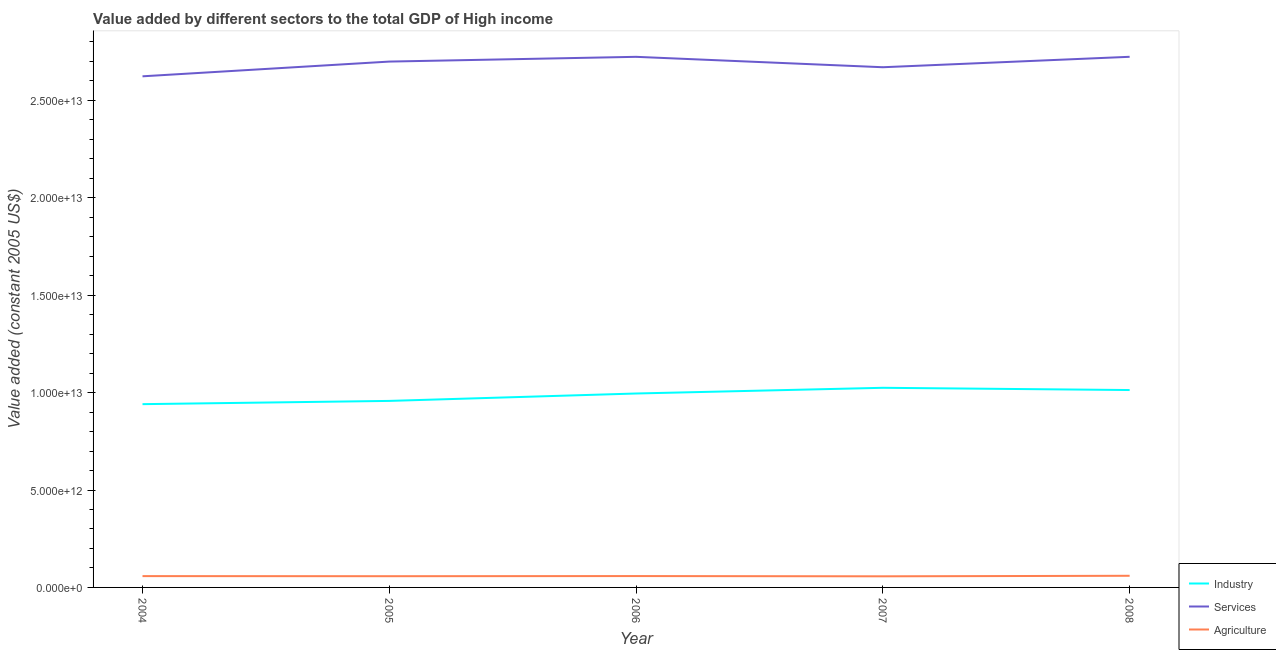Is the number of lines equal to the number of legend labels?
Provide a short and direct response. Yes. What is the value added by services in 2005?
Provide a succinct answer. 2.70e+13. Across all years, what is the maximum value added by services?
Ensure brevity in your answer.  2.72e+13. Across all years, what is the minimum value added by agricultural sector?
Offer a terse response. 5.71e+11. In which year was the value added by services maximum?
Make the answer very short. 2008. In which year was the value added by agricultural sector minimum?
Make the answer very short. 2007. What is the total value added by services in the graph?
Provide a short and direct response. 1.34e+14. What is the difference between the value added by agricultural sector in 2007 and that in 2008?
Provide a succinct answer. -2.67e+1. What is the difference between the value added by industrial sector in 2007 and the value added by services in 2004?
Offer a terse response. -1.60e+13. What is the average value added by industrial sector per year?
Ensure brevity in your answer.  9.86e+12. In the year 2008, what is the difference between the value added by services and value added by industrial sector?
Provide a succinct answer. 1.71e+13. What is the ratio of the value added by services in 2004 to that in 2005?
Offer a very short reply. 0.97. Is the value added by services in 2005 less than that in 2007?
Keep it short and to the point. No. What is the difference between the highest and the second highest value added by agricultural sector?
Offer a terse response. 1.40e+1. What is the difference between the highest and the lowest value added by industrial sector?
Give a very brief answer. 8.39e+11. Is the sum of the value added by agricultural sector in 2005 and 2008 greater than the maximum value added by industrial sector across all years?
Give a very brief answer. No. Does the value added by industrial sector monotonically increase over the years?
Ensure brevity in your answer.  No. Is the value added by services strictly greater than the value added by industrial sector over the years?
Your response must be concise. Yes. Is the value added by agricultural sector strictly less than the value added by services over the years?
Your answer should be compact. Yes. What is the difference between two consecutive major ticks on the Y-axis?
Your answer should be very brief. 5.00e+12. Where does the legend appear in the graph?
Provide a short and direct response. Bottom right. How are the legend labels stacked?
Give a very brief answer. Vertical. What is the title of the graph?
Your response must be concise. Value added by different sectors to the total GDP of High income. What is the label or title of the Y-axis?
Your answer should be compact. Value added (constant 2005 US$). What is the Value added (constant 2005 US$) in Industry in 2004?
Provide a short and direct response. 9.41e+12. What is the Value added (constant 2005 US$) of Services in 2004?
Provide a short and direct response. 2.62e+13. What is the Value added (constant 2005 US$) in Agriculture in 2004?
Offer a very short reply. 5.81e+11. What is the Value added (constant 2005 US$) of Industry in 2005?
Your answer should be very brief. 9.57e+12. What is the Value added (constant 2005 US$) of Services in 2005?
Provide a succinct answer. 2.70e+13. What is the Value added (constant 2005 US$) in Agriculture in 2005?
Provide a short and direct response. 5.76e+11. What is the Value added (constant 2005 US$) of Industry in 2006?
Give a very brief answer. 9.95e+12. What is the Value added (constant 2005 US$) of Services in 2006?
Provide a short and direct response. 2.72e+13. What is the Value added (constant 2005 US$) of Agriculture in 2006?
Provide a short and direct response. 5.84e+11. What is the Value added (constant 2005 US$) in Industry in 2007?
Offer a terse response. 1.02e+13. What is the Value added (constant 2005 US$) of Services in 2007?
Give a very brief answer. 2.67e+13. What is the Value added (constant 2005 US$) in Agriculture in 2007?
Keep it short and to the point. 5.71e+11. What is the Value added (constant 2005 US$) in Industry in 2008?
Provide a succinct answer. 1.01e+13. What is the Value added (constant 2005 US$) of Services in 2008?
Ensure brevity in your answer.  2.72e+13. What is the Value added (constant 2005 US$) in Agriculture in 2008?
Offer a very short reply. 5.98e+11. Across all years, what is the maximum Value added (constant 2005 US$) in Industry?
Offer a terse response. 1.02e+13. Across all years, what is the maximum Value added (constant 2005 US$) in Services?
Keep it short and to the point. 2.72e+13. Across all years, what is the maximum Value added (constant 2005 US$) in Agriculture?
Make the answer very short. 5.98e+11. Across all years, what is the minimum Value added (constant 2005 US$) in Industry?
Provide a succinct answer. 9.41e+12. Across all years, what is the minimum Value added (constant 2005 US$) of Services?
Make the answer very short. 2.62e+13. Across all years, what is the minimum Value added (constant 2005 US$) of Agriculture?
Offer a very short reply. 5.71e+11. What is the total Value added (constant 2005 US$) of Industry in the graph?
Offer a very short reply. 4.93e+13. What is the total Value added (constant 2005 US$) of Services in the graph?
Your answer should be compact. 1.34e+14. What is the total Value added (constant 2005 US$) of Agriculture in the graph?
Your answer should be very brief. 2.91e+12. What is the difference between the Value added (constant 2005 US$) in Industry in 2004 and that in 2005?
Make the answer very short. -1.67e+11. What is the difference between the Value added (constant 2005 US$) of Services in 2004 and that in 2005?
Give a very brief answer. -7.56e+11. What is the difference between the Value added (constant 2005 US$) of Agriculture in 2004 and that in 2005?
Provide a short and direct response. 4.40e+09. What is the difference between the Value added (constant 2005 US$) of Industry in 2004 and that in 2006?
Make the answer very short. -5.47e+11. What is the difference between the Value added (constant 2005 US$) of Services in 2004 and that in 2006?
Keep it short and to the point. -1.00e+12. What is the difference between the Value added (constant 2005 US$) in Agriculture in 2004 and that in 2006?
Your answer should be very brief. -2.66e+09. What is the difference between the Value added (constant 2005 US$) of Industry in 2004 and that in 2007?
Your answer should be compact. -8.39e+11. What is the difference between the Value added (constant 2005 US$) of Services in 2004 and that in 2007?
Give a very brief answer. -4.66e+11. What is the difference between the Value added (constant 2005 US$) of Agriculture in 2004 and that in 2007?
Offer a very short reply. 1.00e+1. What is the difference between the Value added (constant 2005 US$) in Industry in 2004 and that in 2008?
Offer a very short reply. -7.24e+11. What is the difference between the Value added (constant 2005 US$) of Services in 2004 and that in 2008?
Offer a terse response. -1.00e+12. What is the difference between the Value added (constant 2005 US$) of Agriculture in 2004 and that in 2008?
Your response must be concise. -1.66e+1. What is the difference between the Value added (constant 2005 US$) of Industry in 2005 and that in 2006?
Ensure brevity in your answer.  -3.80e+11. What is the difference between the Value added (constant 2005 US$) of Services in 2005 and that in 2006?
Give a very brief answer. -2.44e+11. What is the difference between the Value added (constant 2005 US$) of Agriculture in 2005 and that in 2006?
Your answer should be very brief. -7.05e+09. What is the difference between the Value added (constant 2005 US$) in Industry in 2005 and that in 2007?
Provide a short and direct response. -6.73e+11. What is the difference between the Value added (constant 2005 US$) in Services in 2005 and that in 2007?
Ensure brevity in your answer.  2.90e+11. What is the difference between the Value added (constant 2005 US$) of Agriculture in 2005 and that in 2007?
Provide a succinct answer. 5.63e+09. What is the difference between the Value added (constant 2005 US$) in Industry in 2005 and that in 2008?
Your response must be concise. -5.58e+11. What is the difference between the Value added (constant 2005 US$) in Services in 2005 and that in 2008?
Your answer should be compact. -2.45e+11. What is the difference between the Value added (constant 2005 US$) in Agriculture in 2005 and that in 2008?
Provide a short and direct response. -2.10e+1. What is the difference between the Value added (constant 2005 US$) in Industry in 2006 and that in 2007?
Make the answer very short. -2.92e+11. What is the difference between the Value added (constant 2005 US$) in Services in 2006 and that in 2007?
Offer a terse response. 5.34e+11. What is the difference between the Value added (constant 2005 US$) in Agriculture in 2006 and that in 2007?
Your answer should be very brief. 1.27e+1. What is the difference between the Value added (constant 2005 US$) of Industry in 2006 and that in 2008?
Your answer should be very brief. -1.77e+11. What is the difference between the Value added (constant 2005 US$) in Services in 2006 and that in 2008?
Give a very brief answer. -1.33e+09. What is the difference between the Value added (constant 2005 US$) in Agriculture in 2006 and that in 2008?
Your answer should be very brief. -1.40e+1. What is the difference between the Value added (constant 2005 US$) in Industry in 2007 and that in 2008?
Ensure brevity in your answer.  1.15e+11. What is the difference between the Value added (constant 2005 US$) in Services in 2007 and that in 2008?
Your answer should be very brief. -5.36e+11. What is the difference between the Value added (constant 2005 US$) of Agriculture in 2007 and that in 2008?
Your response must be concise. -2.67e+1. What is the difference between the Value added (constant 2005 US$) of Industry in 2004 and the Value added (constant 2005 US$) of Services in 2005?
Keep it short and to the point. -1.76e+13. What is the difference between the Value added (constant 2005 US$) in Industry in 2004 and the Value added (constant 2005 US$) in Agriculture in 2005?
Your response must be concise. 8.83e+12. What is the difference between the Value added (constant 2005 US$) of Services in 2004 and the Value added (constant 2005 US$) of Agriculture in 2005?
Make the answer very short. 2.57e+13. What is the difference between the Value added (constant 2005 US$) in Industry in 2004 and the Value added (constant 2005 US$) in Services in 2006?
Offer a very short reply. -1.78e+13. What is the difference between the Value added (constant 2005 US$) in Industry in 2004 and the Value added (constant 2005 US$) in Agriculture in 2006?
Provide a succinct answer. 8.82e+12. What is the difference between the Value added (constant 2005 US$) of Services in 2004 and the Value added (constant 2005 US$) of Agriculture in 2006?
Ensure brevity in your answer.  2.57e+13. What is the difference between the Value added (constant 2005 US$) in Industry in 2004 and the Value added (constant 2005 US$) in Services in 2007?
Your response must be concise. -1.73e+13. What is the difference between the Value added (constant 2005 US$) of Industry in 2004 and the Value added (constant 2005 US$) of Agriculture in 2007?
Provide a short and direct response. 8.84e+12. What is the difference between the Value added (constant 2005 US$) of Services in 2004 and the Value added (constant 2005 US$) of Agriculture in 2007?
Ensure brevity in your answer.  2.57e+13. What is the difference between the Value added (constant 2005 US$) in Industry in 2004 and the Value added (constant 2005 US$) in Services in 2008?
Give a very brief answer. -1.78e+13. What is the difference between the Value added (constant 2005 US$) in Industry in 2004 and the Value added (constant 2005 US$) in Agriculture in 2008?
Provide a short and direct response. 8.81e+12. What is the difference between the Value added (constant 2005 US$) of Services in 2004 and the Value added (constant 2005 US$) of Agriculture in 2008?
Keep it short and to the point. 2.56e+13. What is the difference between the Value added (constant 2005 US$) of Industry in 2005 and the Value added (constant 2005 US$) of Services in 2006?
Make the answer very short. -1.77e+13. What is the difference between the Value added (constant 2005 US$) in Industry in 2005 and the Value added (constant 2005 US$) in Agriculture in 2006?
Your response must be concise. 8.99e+12. What is the difference between the Value added (constant 2005 US$) in Services in 2005 and the Value added (constant 2005 US$) in Agriculture in 2006?
Your answer should be very brief. 2.64e+13. What is the difference between the Value added (constant 2005 US$) in Industry in 2005 and the Value added (constant 2005 US$) in Services in 2007?
Offer a very short reply. -1.71e+13. What is the difference between the Value added (constant 2005 US$) of Industry in 2005 and the Value added (constant 2005 US$) of Agriculture in 2007?
Offer a terse response. 9.00e+12. What is the difference between the Value added (constant 2005 US$) of Services in 2005 and the Value added (constant 2005 US$) of Agriculture in 2007?
Your response must be concise. 2.64e+13. What is the difference between the Value added (constant 2005 US$) in Industry in 2005 and the Value added (constant 2005 US$) in Services in 2008?
Give a very brief answer. -1.77e+13. What is the difference between the Value added (constant 2005 US$) in Industry in 2005 and the Value added (constant 2005 US$) in Agriculture in 2008?
Your response must be concise. 8.98e+12. What is the difference between the Value added (constant 2005 US$) of Services in 2005 and the Value added (constant 2005 US$) of Agriculture in 2008?
Provide a short and direct response. 2.64e+13. What is the difference between the Value added (constant 2005 US$) of Industry in 2006 and the Value added (constant 2005 US$) of Services in 2007?
Offer a terse response. -1.67e+13. What is the difference between the Value added (constant 2005 US$) of Industry in 2006 and the Value added (constant 2005 US$) of Agriculture in 2007?
Offer a terse response. 9.38e+12. What is the difference between the Value added (constant 2005 US$) of Services in 2006 and the Value added (constant 2005 US$) of Agriculture in 2007?
Your response must be concise. 2.67e+13. What is the difference between the Value added (constant 2005 US$) of Industry in 2006 and the Value added (constant 2005 US$) of Services in 2008?
Offer a terse response. -1.73e+13. What is the difference between the Value added (constant 2005 US$) of Industry in 2006 and the Value added (constant 2005 US$) of Agriculture in 2008?
Make the answer very short. 9.36e+12. What is the difference between the Value added (constant 2005 US$) in Services in 2006 and the Value added (constant 2005 US$) in Agriculture in 2008?
Keep it short and to the point. 2.66e+13. What is the difference between the Value added (constant 2005 US$) of Industry in 2007 and the Value added (constant 2005 US$) of Services in 2008?
Your response must be concise. -1.70e+13. What is the difference between the Value added (constant 2005 US$) in Industry in 2007 and the Value added (constant 2005 US$) in Agriculture in 2008?
Give a very brief answer. 9.65e+12. What is the difference between the Value added (constant 2005 US$) in Services in 2007 and the Value added (constant 2005 US$) in Agriculture in 2008?
Ensure brevity in your answer.  2.61e+13. What is the average Value added (constant 2005 US$) of Industry per year?
Provide a succinct answer. 9.86e+12. What is the average Value added (constant 2005 US$) of Services per year?
Offer a very short reply. 2.69e+13. What is the average Value added (constant 2005 US$) of Agriculture per year?
Your answer should be compact. 5.82e+11. In the year 2004, what is the difference between the Value added (constant 2005 US$) in Industry and Value added (constant 2005 US$) in Services?
Provide a succinct answer. -1.68e+13. In the year 2004, what is the difference between the Value added (constant 2005 US$) in Industry and Value added (constant 2005 US$) in Agriculture?
Offer a very short reply. 8.83e+12. In the year 2004, what is the difference between the Value added (constant 2005 US$) in Services and Value added (constant 2005 US$) in Agriculture?
Your answer should be compact. 2.57e+13. In the year 2005, what is the difference between the Value added (constant 2005 US$) of Industry and Value added (constant 2005 US$) of Services?
Give a very brief answer. -1.74e+13. In the year 2005, what is the difference between the Value added (constant 2005 US$) of Industry and Value added (constant 2005 US$) of Agriculture?
Offer a terse response. 9.00e+12. In the year 2005, what is the difference between the Value added (constant 2005 US$) of Services and Value added (constant 2005 US$) of Agriculture?
Your answer should be very brief. 2.64e+13. In the year 2006, what is the difference between the Value added (constant 2005 US$) in Industry and Value added (constant 2005 US$) in Services?
Provide a short and direct response. -1.73e+13. In the year 2006, what is the difference between the Value added (constant 2005 US$) in Industry and Value added (constant 2005 US$) in Agriculture?
Keep it short and to the point. 9.37e+12. In the year 2006, what is the difference between the Value added (constant 2005 US$) in Services and Value added (constant 2005 US$) in Agriculture?
Your response must be concise. 2.67e+13. In the year 2007, what is the difference between the Value added (constant 2005 US$) in Industry and Value added (constant 2005 US$) in Services?
Your answer should be compact. -1.65e+13. In the year 2007, what is the difference between the Value added (constant 2005 US$) of Industry and Value added (constant 2005 US$) of Agriculture?
Provide a succinct answer. 9.68e+12. In the year 2007, what is the difference between the Value added (constant 2005 US$) in Services and Value added (constant 2005 US$) in Agriculture?
Provide a succinct answer. 2.61e+13. In the year 2008, what is the difference between the Value added (constant 2005 US$) of Industry and Value added (constant 2005 US$) of Services?
Your response must be concise. -1.71e+13. In the year 2008, what is the difference between the Value added (constant 2005 US$) of Industry and Value added (constant 2005 US$) of Agriculture?
Provide a succinct answer. 9.53e+12. In the year 2008, what is the difference between the Value added (constant 2005 US$) of Services and Value added (constant 2005 US$) of Agriculture?
Offer a terse response. 2.66e+13. What is the ratio of the Value added (constant 2005 US$) of Industry in 2004 to that in 2005?
Provide a succinct answer. 0.98. What is the ratio of the Value added (constant 2005 US$) of Services in 2004 to that in 2005?
Ensure brevity in your answer.  0.97. What is the ratio of the Value added (constant 2005 US$) in Agriculture in 2004 to that in 2005?
Provide a short and direct response. 1.01. What is the ratio of the Value added (constant 2005 US$) of Industry in 2004 to that in 2006?
Keep it short and to the point. 0.95. What is the ratio of the Value added (constant 2005 US$) of Services in 2004 to that in 2006?
Offer a very short reply. 0.96. What is the ratio of the Value added (constant 2005 US$) of Industry in 2004 to that in 2007?
Your answer should be compact. 0.92. What is the ratio of the Value added (constant 2005 US$) in Services in 2004 to that in 2007?
Provide a short and direct response. 0.98. What is the ratio of the Value added (constant 2005 US$) in Agriculture in 2004 to that in 2007?
Your answer should be very brief. 1.02. What is the ratio of the Value added (constant 2005 US$) of Industry in 2004 to that in 2008?
Give a very brief answer. 0.93. What is the ratio of the Value added (constant 2005 US$) in Services in 2004 to that in 2008?
Make the answer very short. 0.96. What is the ratio of the Value added (constant 2005 US$) of Agriculture in 2004 to that in 2008?
Your answer should be compact. 0.97. What is the ratio of the Value added (constant 2005 US$) of Industry in 2005 to that in 2006?
Your answer should be very brief. 0.96. What is the ratio of the Value added (constant 2005 US$) in Agriculture in 2005 to that in 2006?
Your response must be concise. 0.99. What is the ratio of the Value added (constant 2005 US$) of Industry in 2005 to that in 2007?
Your answer should be very brief. 0.93. What is the ratio of the Value added (constant 2005 US$) in Services in 2005 to that in 2007?
Your answer should be compact. 1.01. What is the ratio of the Value added (constant 2005 US$) in Agriculture in 2005 to that in 2007?
Offer a very short reply. 1.01. What is the ratio of the Value added (constant 2005 US$) in Industry in 2005 to that in 2008?
Ensure brevity in your answer.  0.94. What is the ratio of the Value added (constant 2005 US$) in Agriculture in 2005 to that in 2008?
Make the answer very short. 0.96. What is the ratio of the Value added (constant 2005 US$) of Industry in 2006 to that in 2007?
Provide a short and direct response. 0.97. What is the ratio of the Value added (constant 2005 US$) of Services in 2006 to that in 2007?
Your response must be concise. 1.02. What is the ratio of the Value added (constant 2005 US$) in Agriculture in 2006 to that in 2007?
Your response must be concise. 1.02. What is the ratio of the Value added (constant 2005 US$) in Industry in 2006 to that in 2008?
Ensure brevity in your answer.  0.98. What is the ratio of the Value added (constant 2005 US$) of Agriculture in 2006 to that in 2008?
Give a very brief answer. 0.98. What is the ratio of the Value added (constant 2005 US$) in Industry in 2007 to that in 2008?
Your answer should be very brief. 1.01. What is the ratio of the Value added (constant 2005 US$) in Services in 2007 to that in 2008?
Offer a very short reply. 0.98. What is the ratio of the Value added (constant 2005 US$) of Agriculture in 2007 to that in 2008?
Give a very brief answer. 0.96. What is the difference between the highest and the second highest Value added (constant 2005 US$) of Industry?
Your answer should be compact. 1.15e+11. What is the difference between the highest and the second highest Value added (constant 2005 US$) of Services?
Give a very brief answer. 1.33e+09. What is the difference between the highest and the second highest Value added (constant 2005 US$) of Agriculture?
Keep it short and to the point. 1.40e+1. What is the difference between the highest and the lowest Value added (constant 2005 US$) in Industry?
Provide a short and direct response. 8.39e+11. What is the difference between the highest and the lowest Value added (constant 2005 US$) of Services?
Make the answer very short. 1.00e+12. What is the difference between the highest and the lowest Value added (constant 2005 US$) in Agriculture?
Your response must be concise. 2.67e+1. 